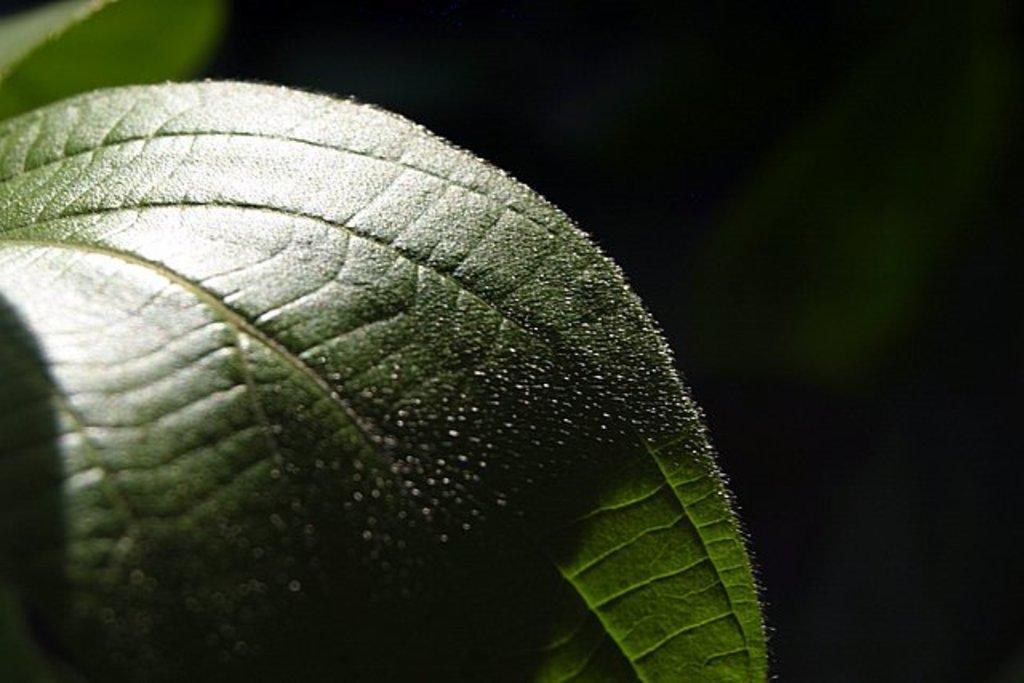Could you give a brief overview of what you see in this image? In this image there is a green colored leaves. There is a dark background. 